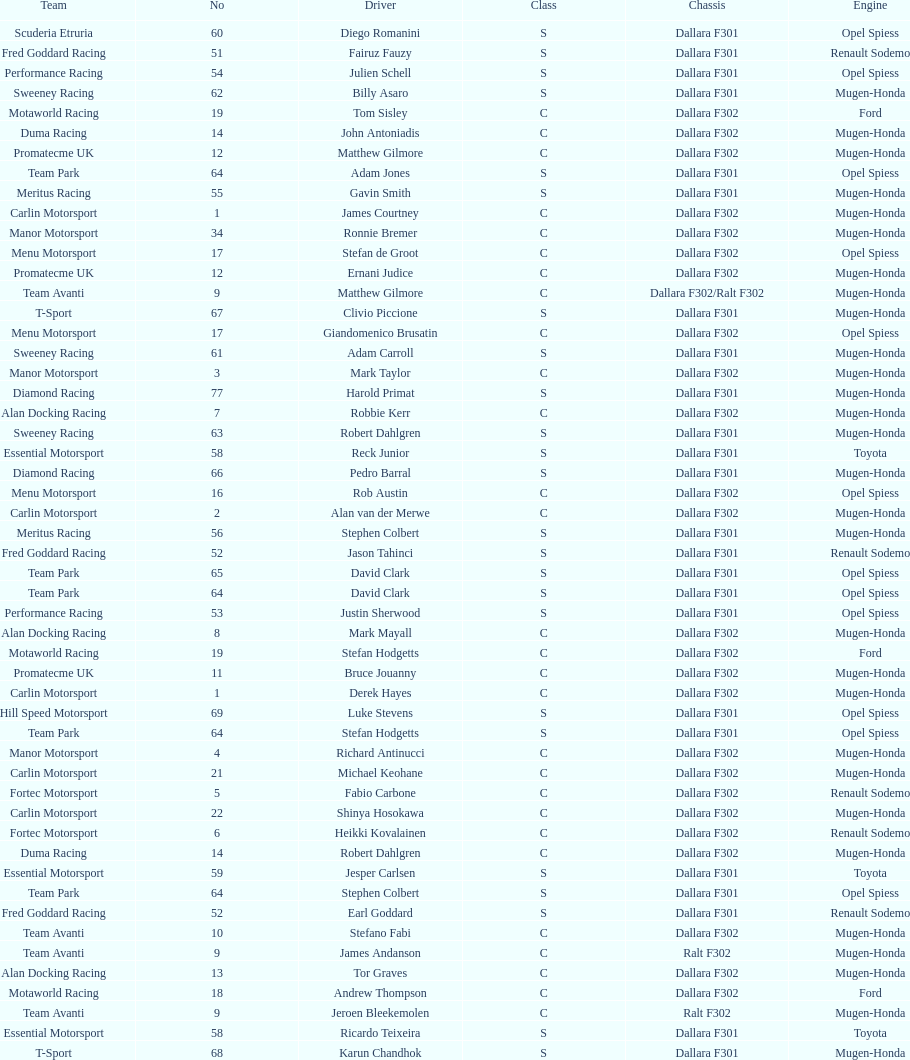Who had more drivers, team avanti or motaworld racing? Team Avanti. 